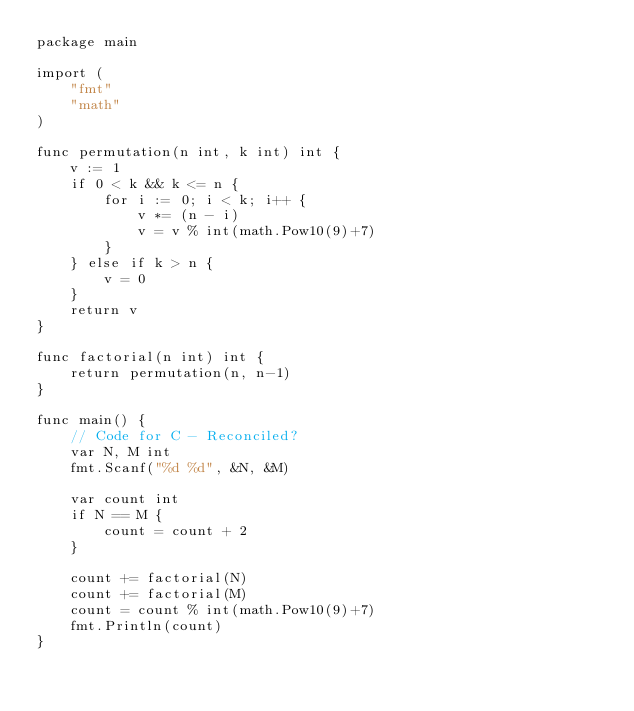Convert code to text. <code><loc_0><loc_0><loc_500><loc_500><_Go_>package main

import (
	"fmt"
	"math"
)

func permutation(n int, k int) int {
	v := 1
	if 0 < k && k <= n {
		for i := 0; i < k; i++ {
			v *= (n - i)
			v = v % int(math.Pow10(9)+7)
		}
	} else if k > n {
		v = 0
	}
	return v
}

func factorial(n int) int {
	return permutation(n, n-1)
}

func main() {
	// Code for C - Reconciled?
	var N, M int
	fmt.Scanf("%d %d", &N, &M)

	var count int
	if N == M {
		count = count + 2
	}

	count += factorial(N)
	count += factorial(M)
	count = count % int(math.Pow10(9)+7)
	fmt.Println(count)
}
</code> 